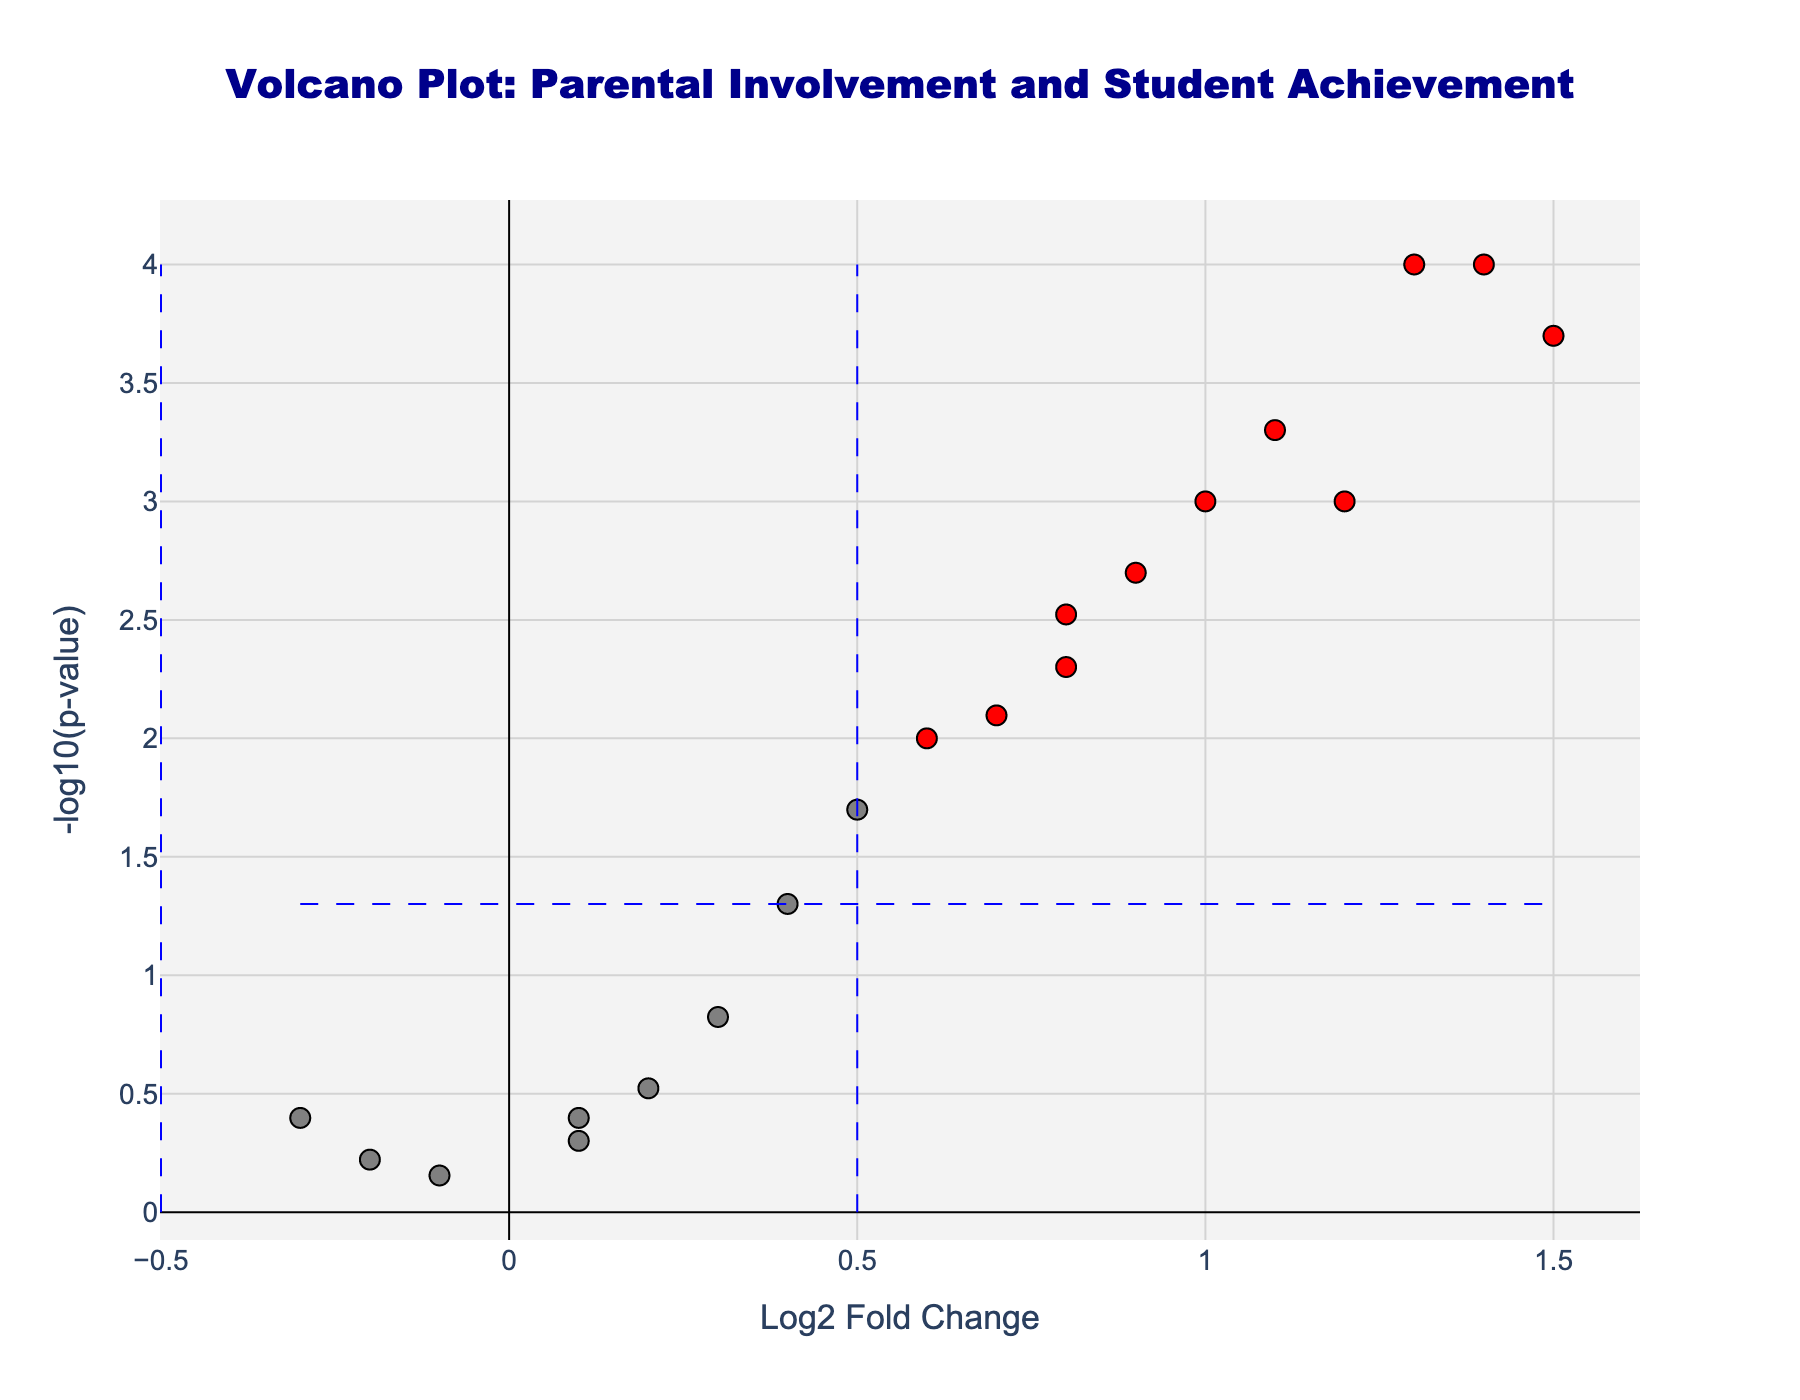What's the title of the plot? The title is usually found at the top of the plot. In this case, it states "Volcano Plot: Parental Involvement and Student Achievement".
Answer: Volcano Plot: Parental Involvement and Student Achievement What do the x-axis and y-axis represent? The labels of the axes indicate what they represent. The x-axis is labeled "Log2 Fold Change", and the y-axis is labeled "-log10(p-value)".
Answer: x-axis: Log2 Fold Change, y-axis: -log10(p-value) How many programs have a statistically significant correlation with student achievement outcomes? Points that are colored red represent programs with statistically significant correlations. There are 13 points colored red in the plot.
Answer: 13 Which program has the highest log2 fold change? By looking at the point that is farthest to the right on the x-axis, we can identify the "After-School Tutoring" program as having the highest log2 fold change.
Answer: After-School Tutoring Which program has the lowest log2 fold change? By observing the point farthest to the left on the x-axis, we identify the "School Safety Patrol" program as having the lowest log2 fold change.
Answer: School Safety Patrol Which program has the smallest p-value? The program with the smallest p-value will have the highest value on the y-axis. This is the "Family Literacy Night" program.
Answer: Family Literacy Night Which programs have both a log2 fold change greater than 0.5 and p-value less than 0.05? Programs that meet these criteria are colored red and to the right of the vertical dashed blue line at 0.5 on the x-axis. This includes: Parent-Teacher Association, Classroom Volunteer Program, After-School Tutoring, Parent Education Workshops, Parent Advisory Council, Family Literacy Night, Science Fair Mentor Program, Technology Integration Team, and Special Education Parent Group.
Answer: 9 Programs What's the log2 fold change and p-value of the "Field Trip Chaperone Program"? By hovering over the point representing the "Field Trip Chaperone Program", you can read the values: Log2 fold change is 0.5 and p-value is 0.02.
Answer: Log2FC: 0.5, p-value: 0.02 Compare the log2 fold change of "School Garden Project" and "School Library Volunteer". Which one is higher? By comparing the x-axis positions of the points for these programs, "School Library Volunteer" has a higher log2 fold change (0.7) compared to "School Garden Project" (-0.2).
Answer: School Library Volunteer 